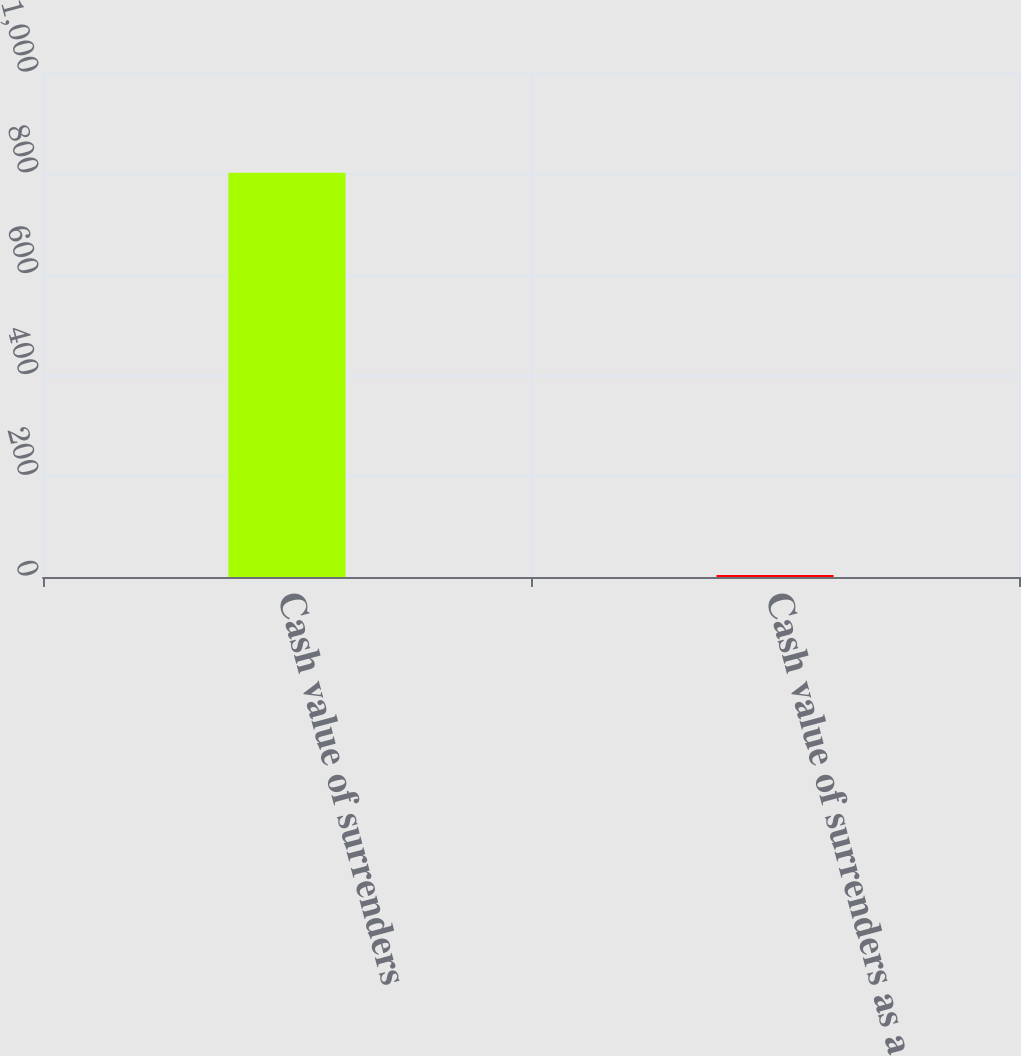Convert chart to OTSL. <chart><loc_0><loc_0><loc_500><loc_500><bar_chart><fcel>Cash value of surrenders<fcel>Cash value of surrenders as a<nl><fcel>802<fcel>3.8<nl></chart> 